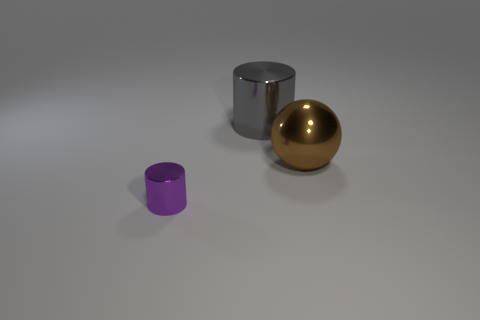Add 2 tiny blue metal spheres. How many objects exist? 5 Subtract all cylinders. How many objects are left? 1 Subtract 0 red balls. How many objects are left? 3 Subtract all small brown shiny balls. Subtract all small purple metal cylinders. How many objects are left? 2 Add 2 large gray cylinders. How many large gray cylinders are left? 3 Add 1 big red cubes. How many big red cubes exist? 1 